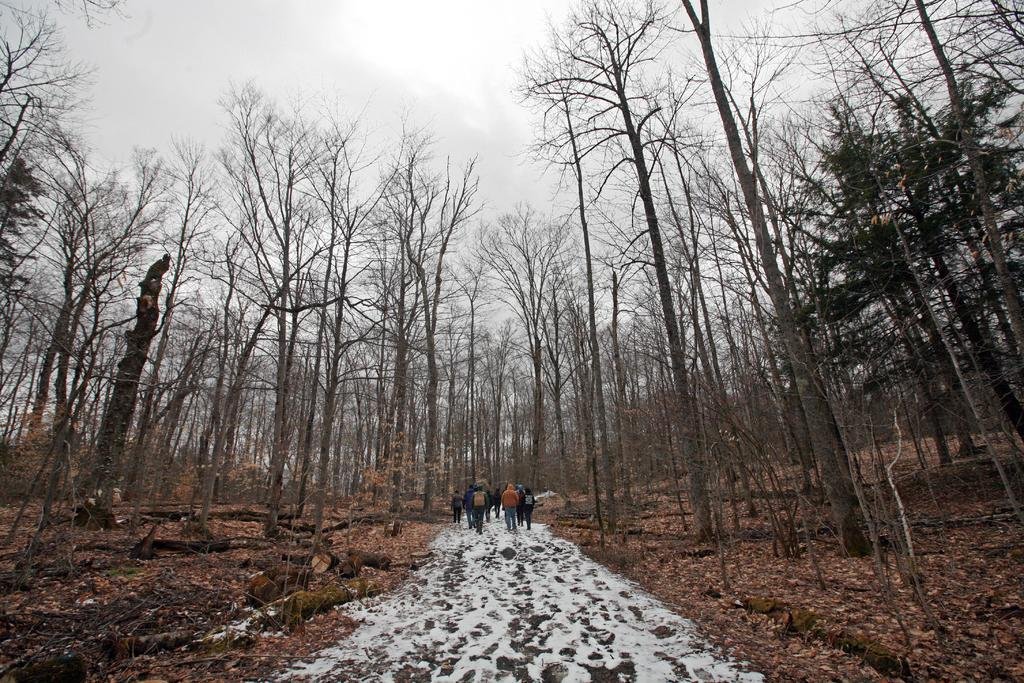Who or what is present in the image? There are people in the image. What is the weather like in the image? There is snow in the image, indicating a cold and wintry scene. What type of vegetation can be seen in the image? There are trees in the image. What is on the ground in the image? Leaves are present on the ground. What can be seen in the background of the image? The sky is visible in the background of the image. What type of circle can be seen on the sign in the image? There is no sign or circle present in the image. How does the throat of the person in the image feel in the cold weather? There is no information about the person's throat or feelings in the image. 